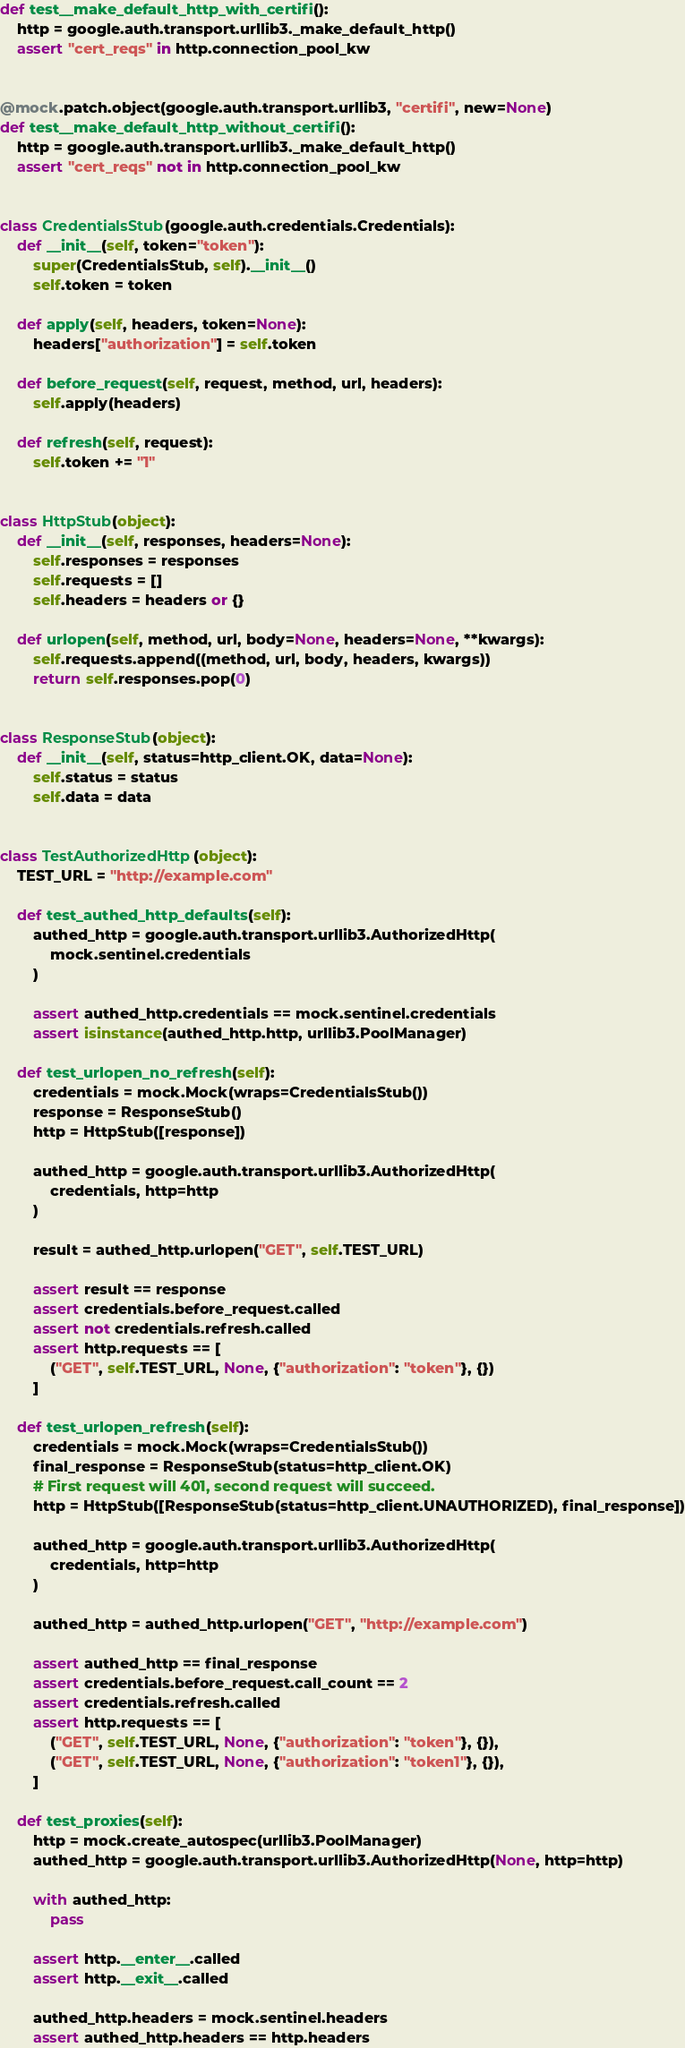Convert code to text. <code><loc_0><loc_0><loc_500><loc_500><_Python_>def test__make_default_http_with_certifi():
    http = google.auth.transport.urllib3._make_default_http()
    assert "cert_reqs" in http.connection_pool_kw


@mock.patch.object(google.auth.transport.urllib3, "certifi", new=None)
def test__make_default_http_without_certifi():
    http = google.auth.transport.urllib3._make_default_http()
    assert "cert_reqs" not in http.connection_pool_kw


class CredentialsStub(google.auth.credentials.Credentials):
    def __init__(self, token="token"):
        super(CredentialsStub, self).__init__()
        self.token = token

    def apply(self, headers, token=None):
        headers["authorization"] = self.token

    def before_request(self, request, method, url, headers):
        self.apply(headers)

    def refresh(self, request):
        self.token += "1"


class HttpStub(object):
    def __init__(self, responses, headers=None):
        self.responses = responses
        self.requests = []
        self.headers = headers or {}

    def urlopen(self, method, url, body=None, headers=None, **kwargs):
        self.requests.append((method, url, body, headers, kwargs))
        return self.responses.pop(0)


class ResponseStub(object):
    def __init__(self, status=http_client.OK, data=None):
        self.status = status
        self.data = data


class TestAuthorizedHttp(object):
    TEST_URL = "http://example.com"

    def test_authed_http_defaults(self):
        authed_http = google.auth.transport.urllib3.AuthorizedHttp(
            mock.sentinel.credentials
        )

        assert authed_http.credentials == mock.sentinel.credentials
        assert isinstance(authed_http.http, urllib3.PoolManager)

    def test_urlopen_no_refresh(self):
        credentials = mock.Mock(wraps=CredentialsStub())
        response = ResponseStub()
        http = HttpStub([response])

        authed_http = google.auth.transport.urllib3.AuthorizedHttp(
            credentials, http=http
        )

        result = authed_http.urlopen("GET", self.TEST_URL)

        assert result == response
        assert credentials.before_request.called
        assert not credentials.refresh.called
        assert http.requests == [
            ("GET", self.TEST_URL, None, {"authorization": "token"}, {})
        ]

    def test_urlopen_refresh(self):
        credentials = mock.Mock(wraps=CredentialsStub())
        final_response = ResponseStub(status=http_client.OK)
        # First request will 401, second request will succeed.
        http = HttpStub([ResponseStub(status=http_client.UNAUTHORIZED), final_response])

        authed_http = google.auth.transport.urllib3.AuthorizedHttp(
            credentials, http=http
        )

        authed_http = authed_http.urlopen("GET", "http://example.com")

        assert authed_http == final_response
        assert credentials.before_request.call_count == 2
        assert credentials.refresh.called
        assert http.requests == [
            ("GET", self.TEST_URL, None, {"authorization": "token"}, {}),
            ("GET", self.TEST_URL, None, {"authorization": "token1"}, {}),
        ]

    def test_proxies(self):
        http = mock.create_autospec(urllib3.PoolManager)
        authed_http = google.auth.transport.urllib3.AuthorizedHttp(None, http=http)

        with authed_http:
            pass

        assert http.__enter__.called
        assert http.__exit__.called

        authed_http.headers = mock.sentinel.headers
        assert authed_http.headers == http.headers
</code> 